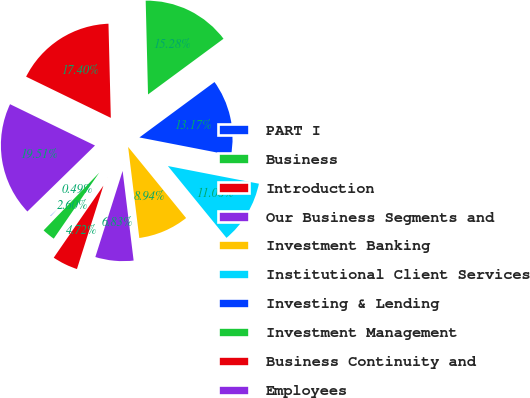<chart> <loc_0><loc_0><loc_500><loc_500><pie_chart><fcel>PART I<fcel>Business<fcel>Introduction<fcel>Our Business Segments and<fcel>Investment Banking<fcel>Institutional Client Services<fcel>Investing & Lending<fcel>Investment Management<fcel>Business Continuity and<fcel>Employees<nl><fcel>0.49%<fcel>2.6%<fcel>4.72%<fcel>6.83%<fcel>8.94%<fcel>11.06%<fcel>13.17%<fcel>15.28%<fcel>17.4%<fcel>19.51%<nl></chart> 